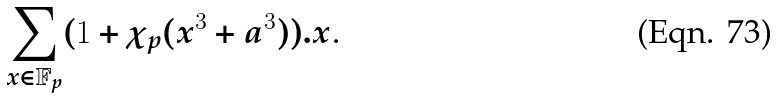Convert formula to latex. <formula><loc_0><loc_0><loc_500><loc_500>\underset { x \in \mathbb { F } _ { p } } { \sum } ( 1 + \chi _ { p } ( x ^ { 3 } + a ^ { 3 } ) ) . x \text {.}</formula> 